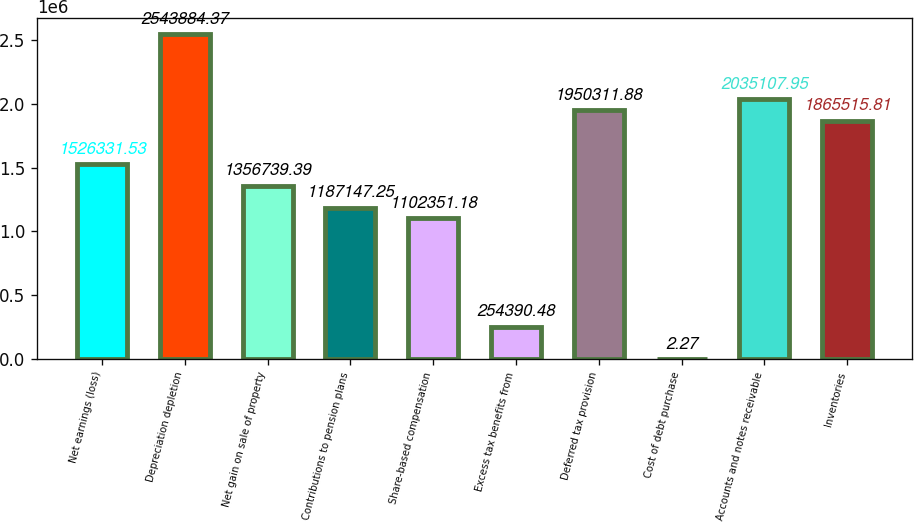Convert chart. <chart><loc_0><loc_0><loc_500><loc_500><bar_chart><fcel>Net earnings (loss)<fcel>Depreciation depletion<fcel>Net gain on sale of property<fcel>Contributions to pension plans<fcel>Share-based compensation<fcel>Excess tax benefits from<fcel>Deferred tax provision<fcel>Cost of debt purchase<fcel>Accounts and notes receivable<fcel>Inventories<nl><fcel>1.52633e+06<fcel>2.54388e+06<fcel>1.35674e+06<fcel>1.18715e+06<fcel>1.10235e+06<fcel>254390<fcel>1.95031e+06<fcel>2.27<fcel>2.03511e+06<fcel>1.86552e+06<nl></chart> 